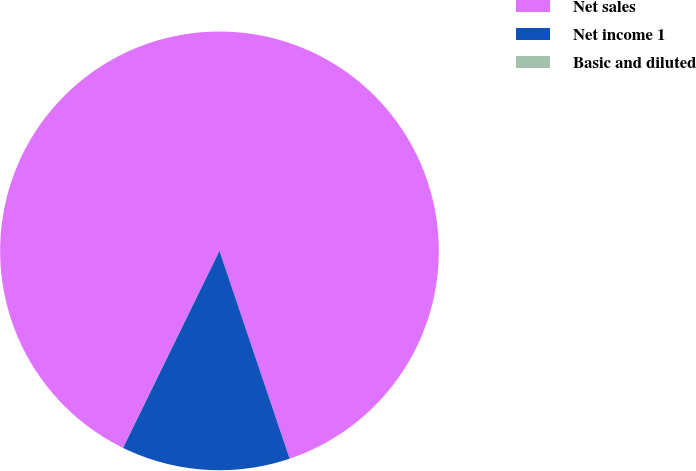<chart> <loc_0><loc_0><loc_500><loc_500><pie_chart><fcel>Net sales<fcel>Net income 1<fcel>Basic and diluted<nl><fcel>87.56%<fcel>12.43%<fcel>0.01%<nl></chart> 